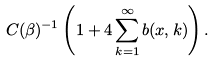Convert formula to latex. <formula><loc_0><loc_0><loc_500><loc_500>C ( \beta ) ^ { - 1 } \left ( 1 + 4 \sum _ { k = 1 } ^ { \infty } b ( x , k ) \right ) .</formula> 